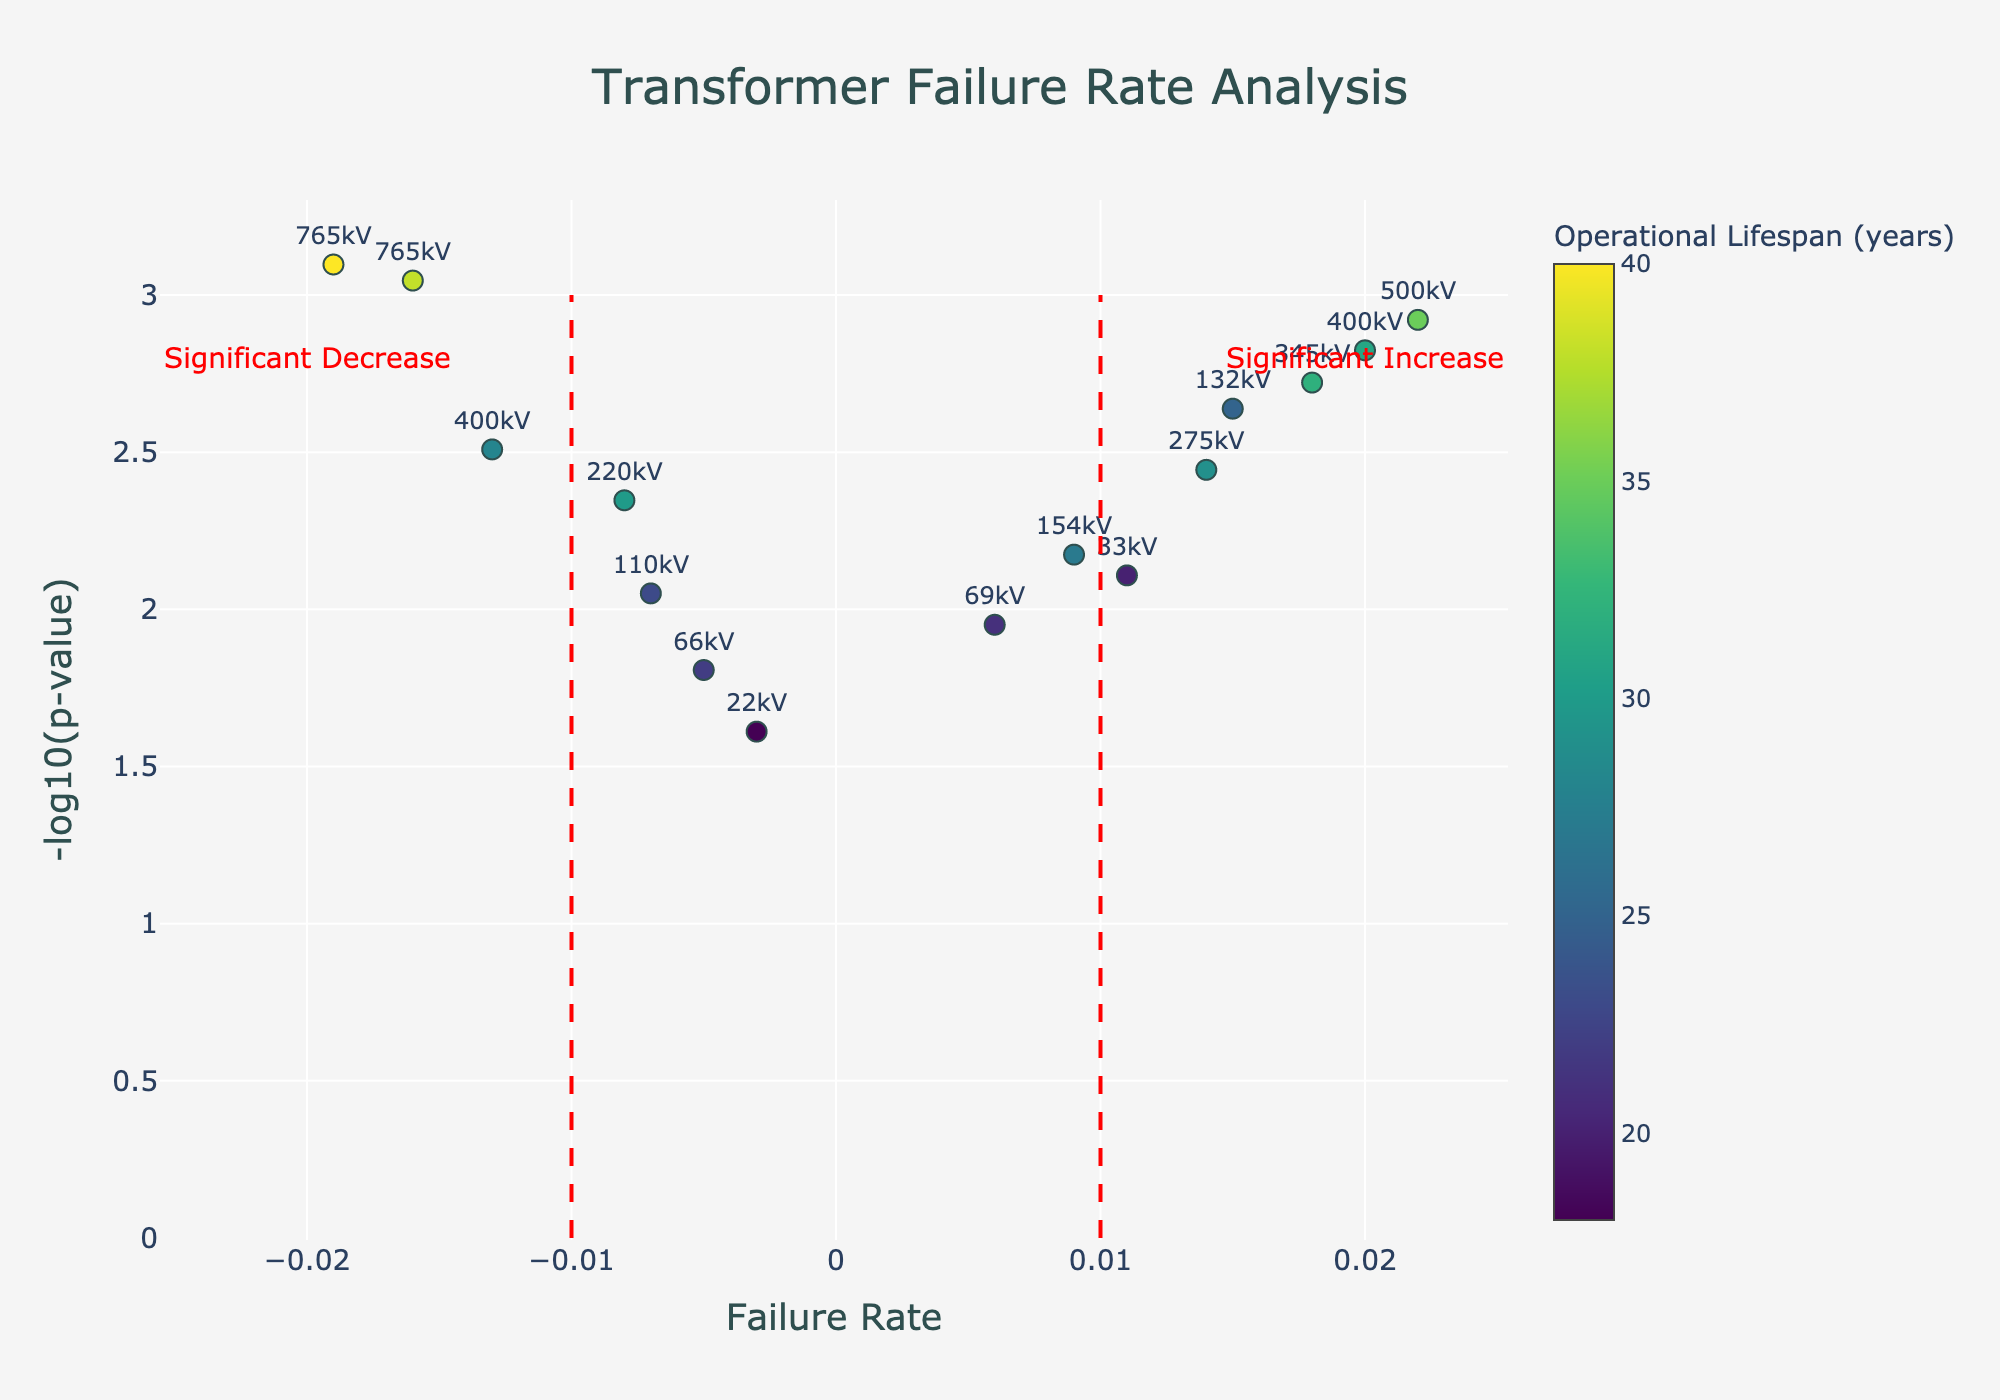What is the title of the plot? The title is clearly displayed at the top center of the plot. It reads "Transformer Failure Rate Analysis."
Answer: Transformer Failure Rate Analysis What do the x-axis and y-axis represent? The x-axis represents the failure rate, while the y-axis represents -log10(p-value). These descriptions are displayed next to each axis on the plot.
Answer: Failure rate and -log10(p-value) Which transformer has the highest operational lifespan, and what is its corresponding voltage rating? By examining the color gradient and hovertext when hovering over the data points, the transformer with the highest operational lifespan is Hitachi with a voltage rating of 765kV.
Answer: Hitachi, 765kV How many transformers have a failure rate greater than 0.01? Identify the points to the right of the vertical line at 0.01 on the x-axis. There are 6 such transformers.
Answer: 6 Which transformer data points indicate a statistically significant decrease in failure rate, and what are their voltage ratings? Data points on the left of the vertical line at -0.01 on the x-axis with high -log10(p-value) values indicate significant decrease. These are Siemens (220kV), Hitachi (765kV), Mitsubishi Electric (400kV), Hyosung (765kV), and Eaton (66kV).
Answer: Siemens, 220kV; Hitachi, 765kV; Mitsubishi Electric, 400kV; Hyosung, 765kV; Eaton, 66kV What is the failure rate of the transformer with the lowest p-value? The transformer with the lowest p-value can be determined by finding the highest point on the y-axis. This is Hitachi, with a failure rate of -0.019.
Answer: -0.019 Which transformer shows the largest failure rate? By examining the x-axis, the largest failure rate is at the extreme right point, which belongs to General Electric with a rate of 0.022.
Answer: General Electric Compare the operational lifespan of ABB and Schneider Electric transformers. Which one lasts longer, and by how many years? ABB has an operational lifespan of 25 years, while Schneider Electric has 20 years. So, ABB lasts 5 years longer.
Answer: ABB, 5 years How many transformers have a positive failure rate and a -log10(p-value) greater than 2? Identify points with a failure rate greater than 0 and a height on the y-axis greater than 2. There are 3 such transformers: ABB, General Electric, and Toshiba.
Answer: 3 Which company’s transformer data point is closest to the origin, and what is its voltage rating? The closest to the origin can be found by looking for the point near (0, 0). This is CG Power Systems with a voltage rating of 22kV.
Answer: CG Power Systems, 22kV 